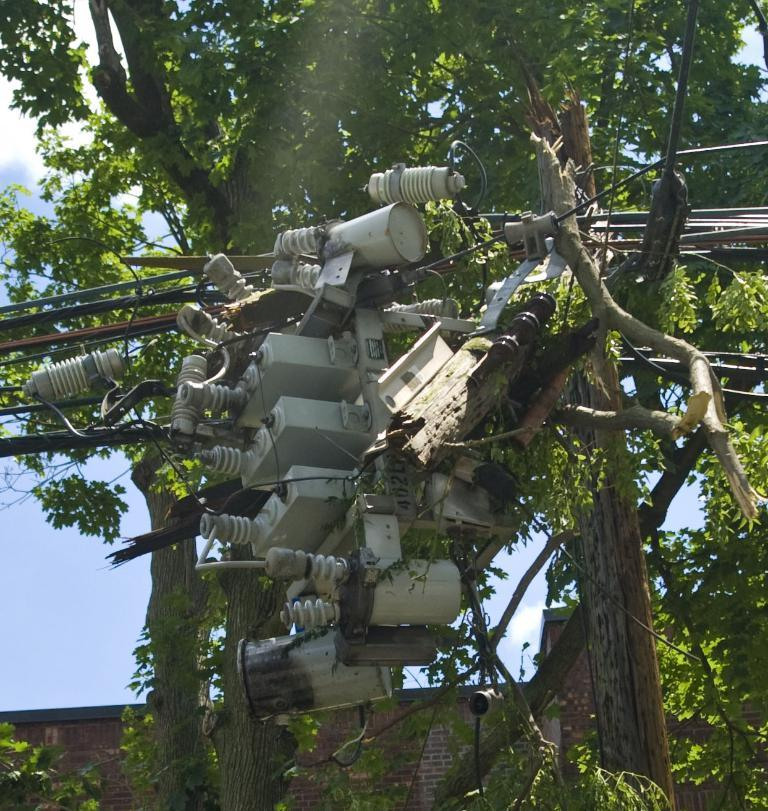What is the main object in the center of the image? There is a transformer in the center of the image. What else can be seen in the center of the image? There are wires in the center of the image. What can be seen in the background of the image? There are trees, a building, and the sky visible in the background of the image. How many times does the jelly sneeze in the image? There is no jelly or sneezing in the image; it features a transformer and wires in the center, with trees, a building, and the sky in the background. 